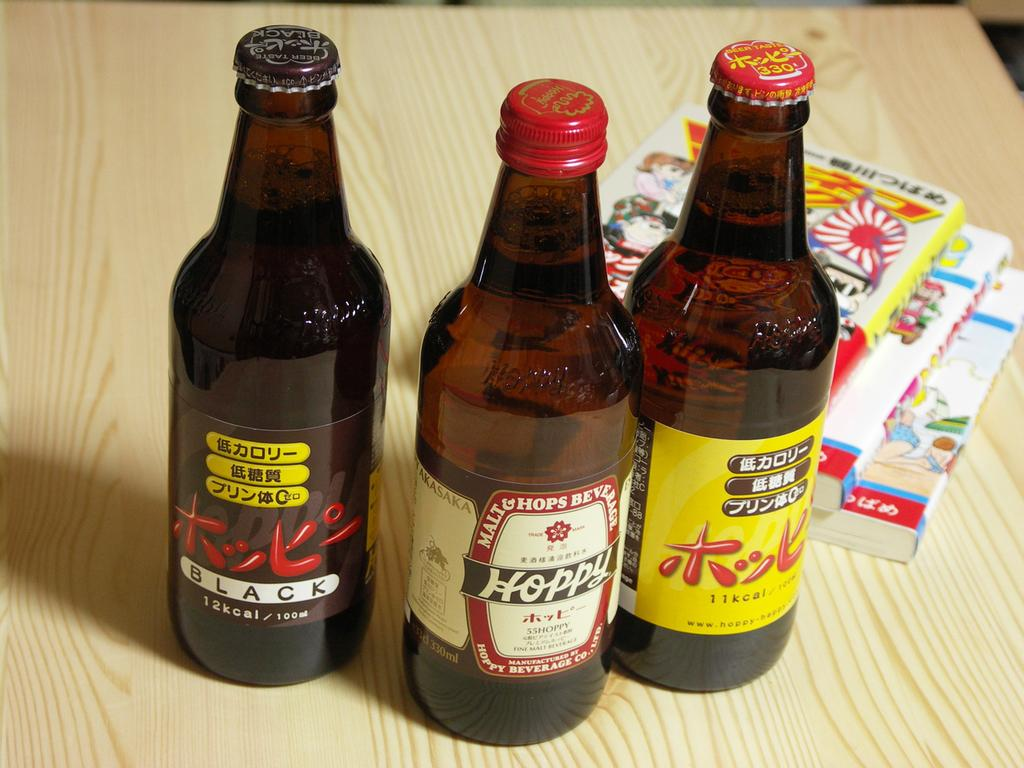<image>
Provide a brief description of the given image. The bottle of Hoppy is standing on the wooden table 